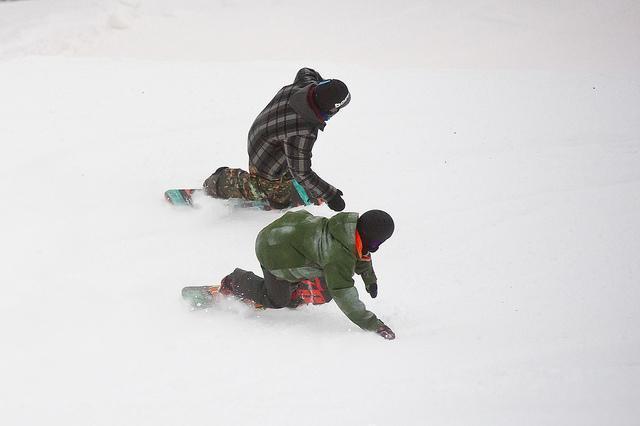What is the person on the right's hand touching?
Make your selection from the four choices given to correctly answer the question.
Options: Cat, snow, donkey, tree. Snow. 